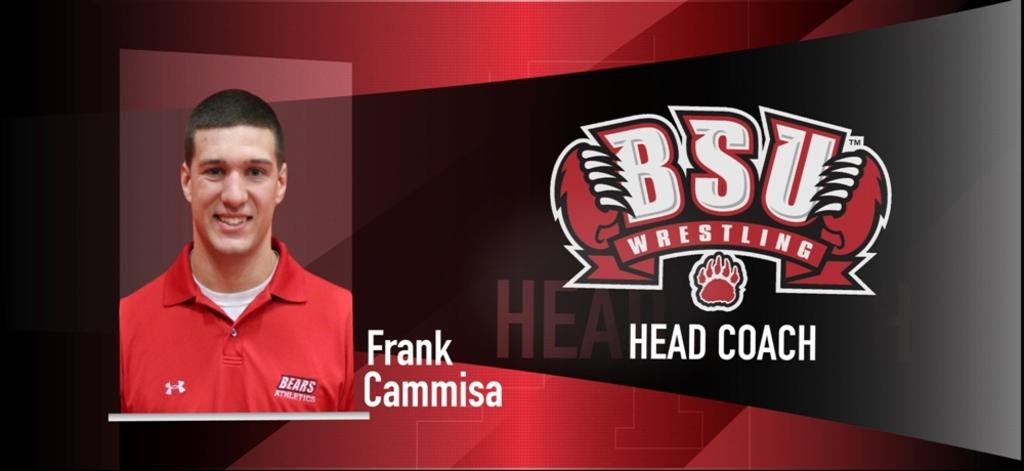<image>
Share a concise interpretation of the image provided. a man that has Frank Cammisa next to his avatar 